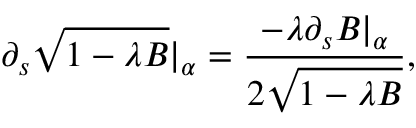Convert formula to latex. <formula><loc_0><loc_0><loc_500><loc_500>\partial _ { s } \sqrt { 1 - \lambda B } | _ { \alpha } = \frac { - \lambda \partial _ { s } B | _ { \alpha } } { 2 \sqrt { 1 - \lambda B } } ,</formula> 